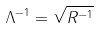Convert formula to latex. <formula><loc_0><loc_0><loc_500><loc_500>\Lambda ^ { - 1 } = \sqrt { R ^ { - 1 } }</formula> 